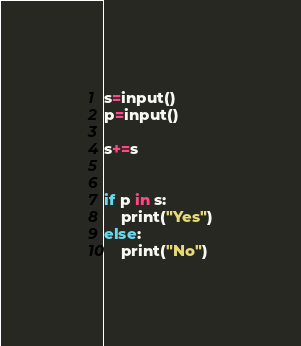Convert code to text. <code><loc_0><loc_0><loc_500><loc_500><_Python_>s=input()
p=input()

s+=s


if p in s:
    print("Yes")
else:
    print("No")

</code> 